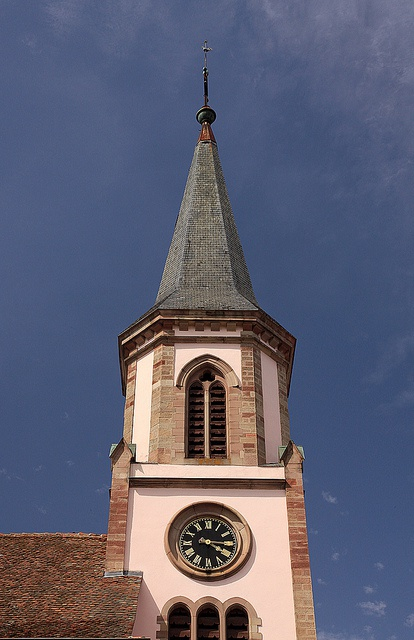Describe the objects in this image and their specific colors. I can see a clock in gray, black, and maroon tones in this image. 